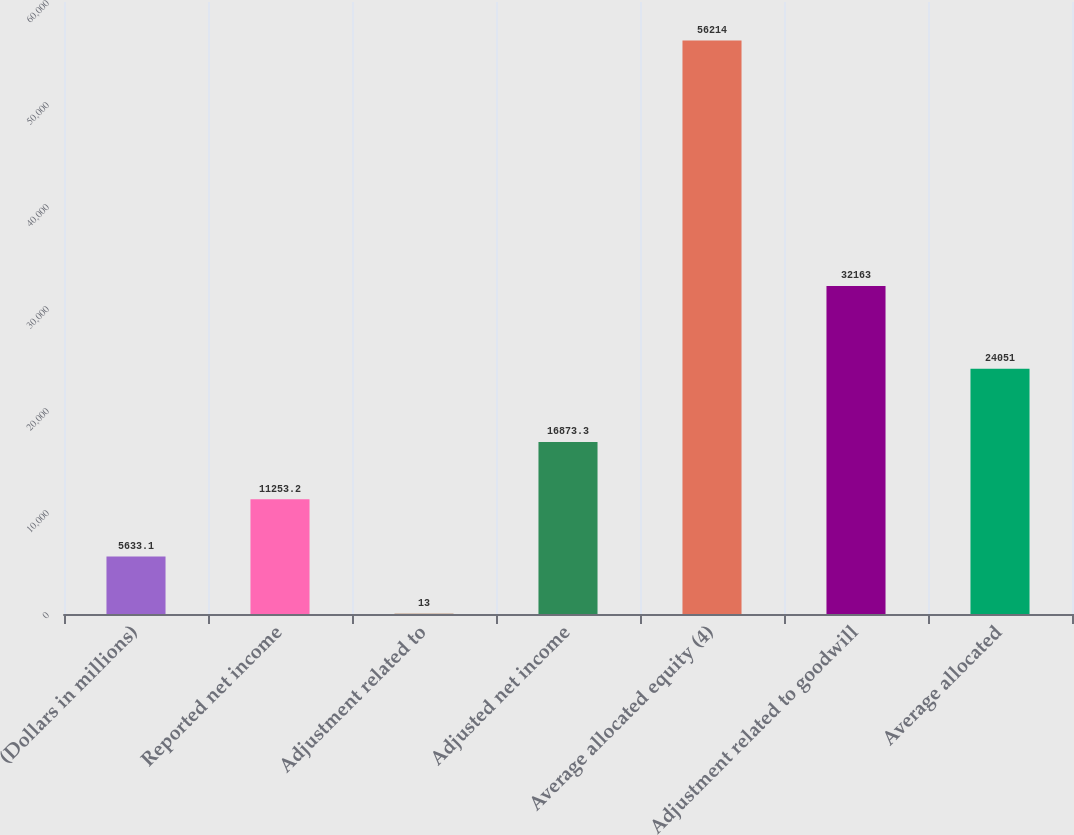Convert chart to OTSL. <chart><loc_0><loc_0><loc_500><loc_500><bar_chart><fcel>(Dollars in millions)<fcel>Reported net income<fcel>Adjustment related to<fcel>Adjusted net income<fcel>Average allocated equity (4)<fcel>Adjustment related to goodwill<fcel>Average allocated<nl><fcel>5633.1<fcel>11253.2<fcel>13<fcel>16873.3<fcel>56214<fcel>32163<fcel>24051<nl></chart> 